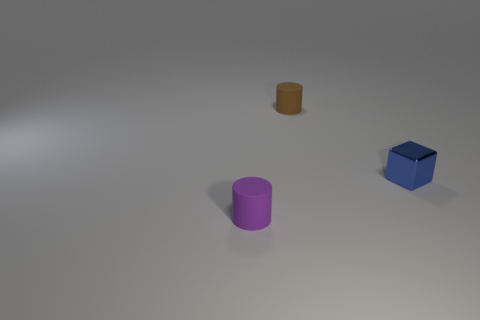How many small blue objects are made of the same material as the tiny brown object? Upon observing the image, it appears that the materials of the objects cannot be determined with absolute certainty solely from visual inspection. However, if the objects are assumed to share material properties based on similar surface characteristics, such as matte finish or lack of reflection, then it could be speculated that none of the objects, including the blue object, share the same material as the tiny brown object. 